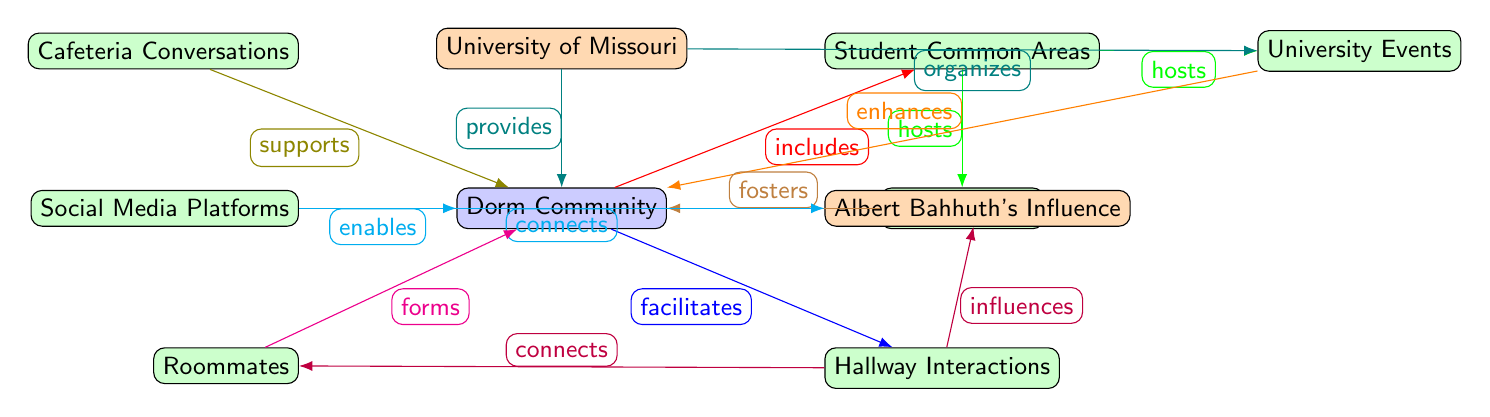What is the central node in the diagram? The central node in the diagram is the Dorm Community, as it is at the center of the surrounding nodes and connections, indicating it is the main focus of the study regarding dorm life.
Answer: Dorm Community How many misc nodes are there? In the diagram, there are seven misc nodes: Student Common Areas, University Events, Hallway Interactions, Study Groups, Social Media Platforms, Roommates, and Cafeteria Conversations, which contribute to various interactions and networking strategies.
Answer: 7 What color is the node representing Albert Bahhuth's Influence? The node representing Albert Bahhuth's Influence is colored in accent style, which is a light orange shade, easily distinguishable from the other node categories.
Answer: Accent Which two nodes are connected by the relationship 'hosts'? The two nodes connected by the relationship 'hosts' are Student Common Areas and University Events, as well as between Student Common Areas and Study Groups, indicating their roles in facilitating social interactions.
Answer: University Events, Study Groups What role do Hallway Interactions play in relation to Roommates? Hallway Interactions connect with Roommates, highlighting that informal encounters in hallways can form or strengthen roommate relationships, demonstrating the importance of physical space in building social ties.
Answer: Connects How many edges does the Dorm Community node have? The Dorm Community node has six edges connecting it to other nodes, demonstrating the various ways through which social interactions and networking strategies are facilitated within the dorm life context.
Answer: 6 What does the node Cafeteria Conversations support? The Cafeteria Conversations node supports the Dorm Community, indicating that interactions and discussions in the cafeteria play a role in strengthening the sense of community among dorm residents.
Answer: Dorm Community What is the relationship between Social Media Platforms and the Dorm Community? The relationship between Social Media Platforms and the Dorm Community is described as 'enables,' suggesting that social media serves to facilitate the connections and interactions among members of the dorm community.
Answer: Enables 